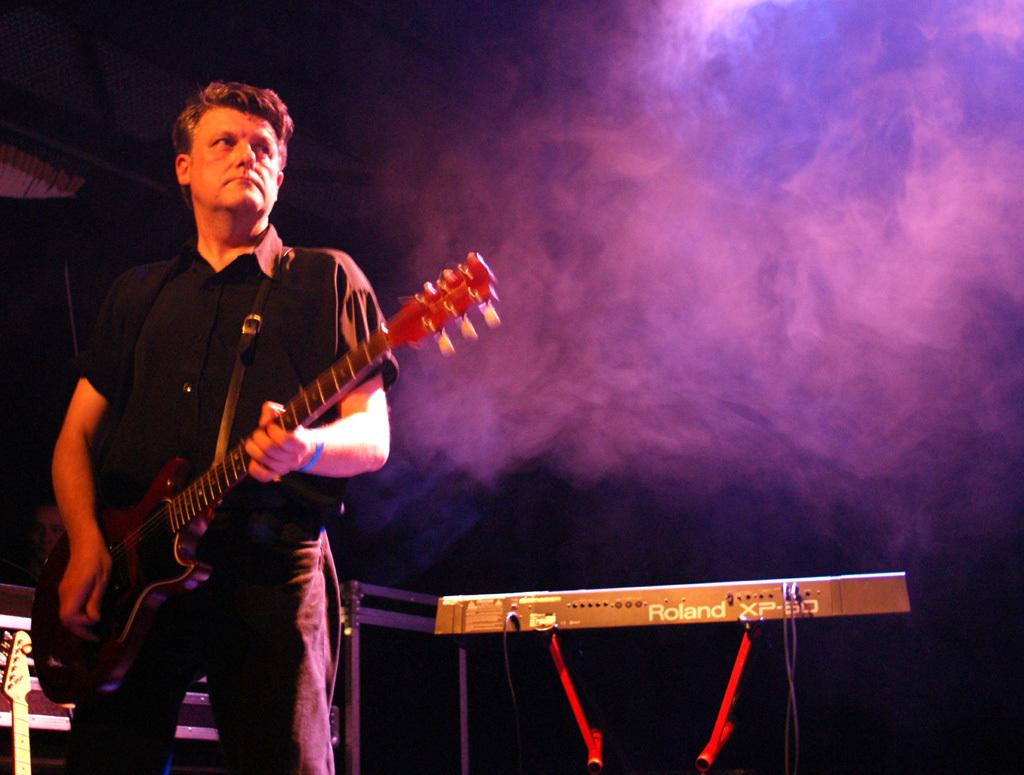What is the person in the image doing? The person is playing a guitar in the image. Are there any other musical instruments visible in the image? Yes, there are musical instruments in the corner of the image. What is the position of the second person in the image? There is a person sitting in the image. What is the weather like in the image? Snow is visible in the image, indicating a cold or wintry setting. What type of stew is being prepared in the image? There is no stew present in the image; it features a person playing a guitar and other musical instruments. What is the person learning in the image? The image does not show the person learning anything specific; they are playing a guitar. 